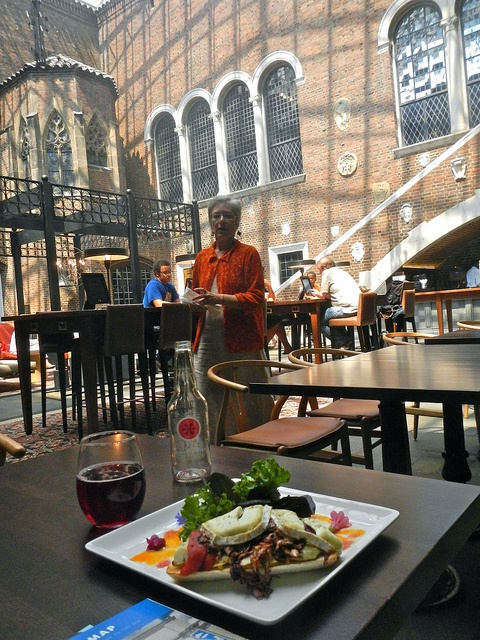Describe the objects in this image and their specific colors. I can see dining table in gray, black, darkgreen, and darkgray tones, people in gray, black, maroon, and brown tones, sandwich in gray, black, olive, and maroon tones, dining table in gray, tan, and black tones, and chair in gray, black, and maroon tones in this image. 